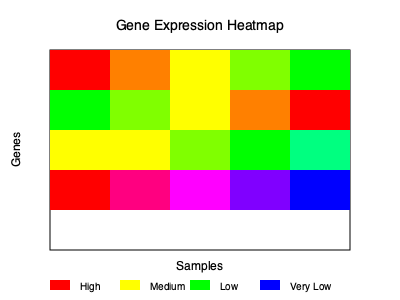Based on the gene expression heatmap shown, which of the following statements is most accurate regarding the expression pattern of the gene represented in the bottom row?
A) It shows a gradual increase in expression from left to right
B) It exhibits a uniform expression level across all samples
C) It demonstrates a progressive decrease in expression from left to right
D) It displays a bimodal expression pattern To analyze the expression pattern of the gene represented in the bottom row of the heatmap, we need to follow these steps:

1. Identify the bottom row: The bottom row is the fourth row from the top in the heatmap.

2. Examine the color pattern: 
   - Left-most cell: Red (indicating high expression)
   - Second cell: Pink (indicating high to medium-high expression)
   - Middle cell: Magenta (indicating medium expression)
   - Fourth cell: Purple (indicating medium-low expression)
   - Right-most cell: Blue (indicating low expression)

3. Interpret the color gradient:
   - In gene expression heatmaps, red typically represents high expression, while blue represents low expression.
   - The colors in between (pink, magenta, purple) represent intermediate levels of expression.

4. Analyze the pattern:
   - We observe a gradual shift from red (high expression) on the left to blue (low expression) on the right.
   - This indicates a progressive decrease in gene expression from left to right across the samples.

5. Compare with the given options:
   A) Incorrect: The expression decreases, not increases, from left to right.
   B) Incorrect: The expression is not uniform across samples.
   C) Correct: The expression shows a progressive decrease from left to right.
   D) Incorrect: The pattern is not bimodal (having two distinct peaks or levels).

Therefore, the most accurate statement is option C: It demonstrates a progressive decrease in expression from left to right.
Answer: C) It demonstrates a progressive decrease in expression from left to right 